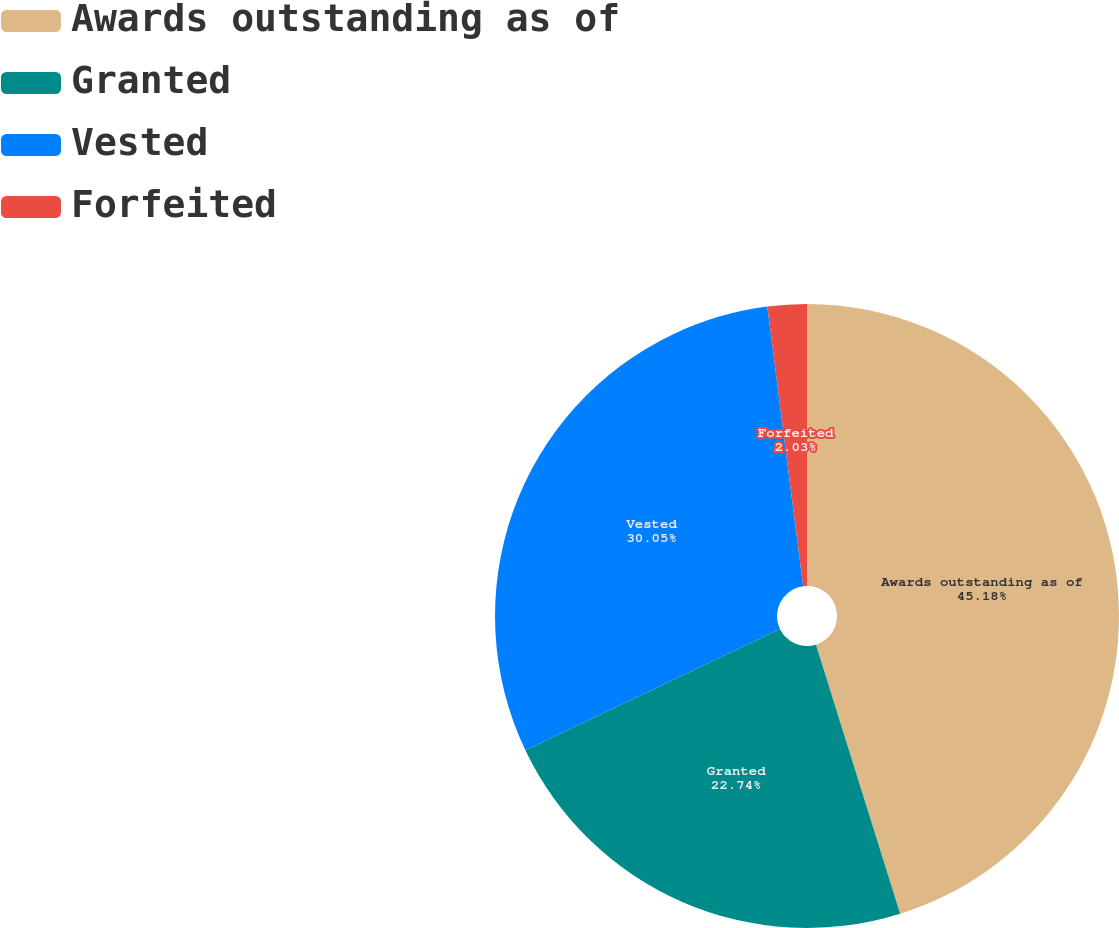<chart> <loc_0><loc_0><loc_500><loc_500><pie_chart><fcel>Awards outstanding as of<fcel>Granted<fcel>Vested<fcel>Forfeited<nl><fcel>45.17%<fcel>22.74%<fcel>30.05%<fcel>2.03%<nl></chart> 